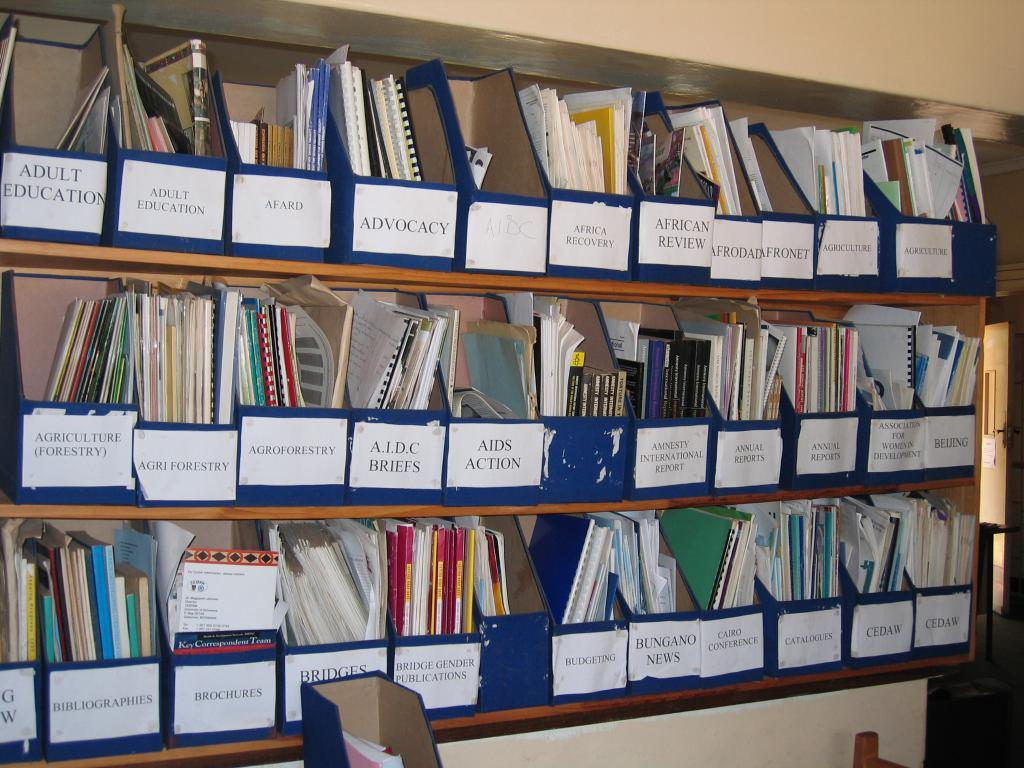<image>
Summarize the visual content of the image. A shelf of binders that have been organized into named boxes some for Adult Education 